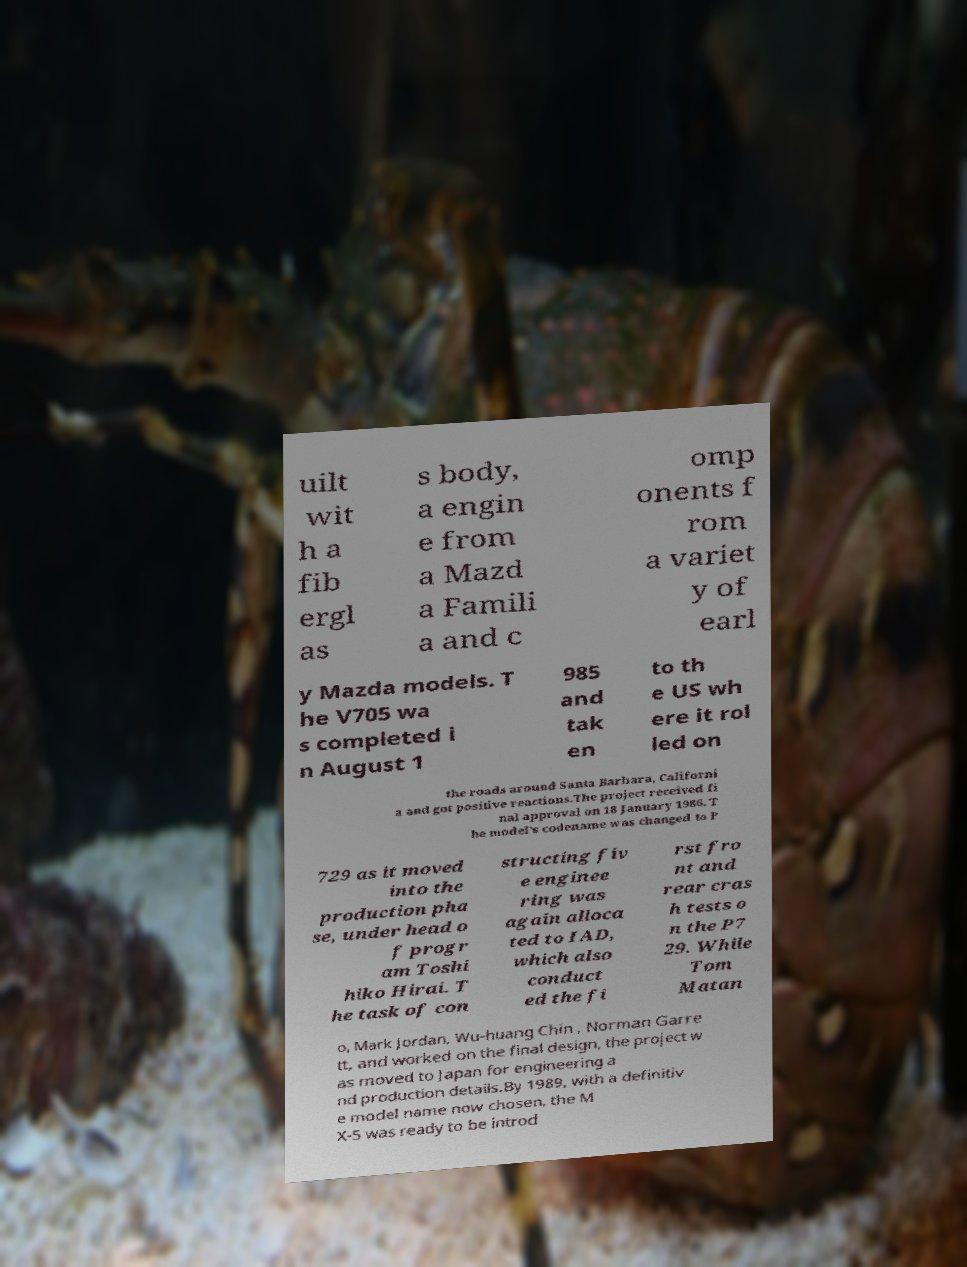Can you read and provide the text displayed in the image?This photo seems to have some interesting text. Can you extract and type it out for me? uilt wit h a fib ergl as s body, a engin e from a Mazd a Famili a and c omp onents f rom a variet y of earl y Mazda models. T he V705 wa s completed i n August 1 985 and tak en to th e US wh ere it rol led on the roads around Santa Barbara, Californi a and got positive reactions.The project received fi nal approval on 18 January 1986. T he model's codename was changed to P 729 as it moved into the production pha se, under head o f progr am Toshi hiko Hirai. T he task of con structing fiv e enginee ring was again alloca ted to IAD, which also conduct ed the fi rst fro nt and rear cras h tests o n the P7 29. While Tom Matan o, Mark Jordan, Wu-huang Chin , Norman Garre tt, and worked on the final design, the project w as moved to Japan for engineering a nd production details.By 1989, with a definitiv e model name now chosen, the M X-5 was ready to be introd 